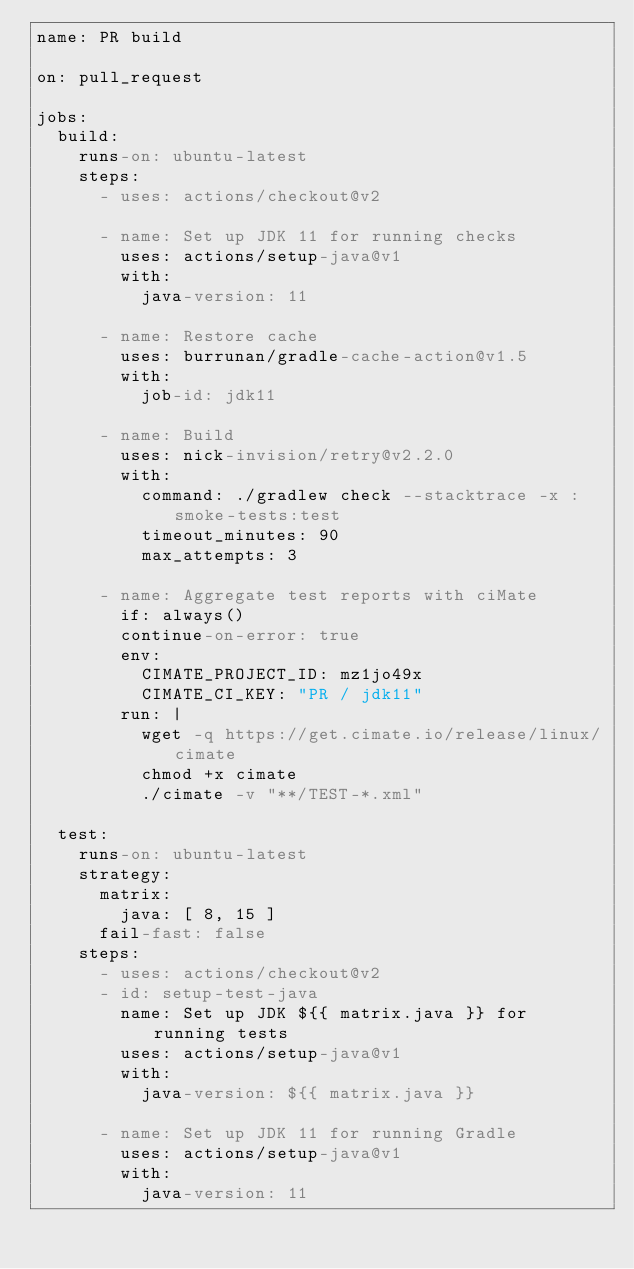<code> <loc_0><loc_0><loc_500><loc_500><_YAML_>name: PR build

on: pull_request

jobs:
  build:
    runs-on: ubuntu-latest
    steps:
      - uses: actions/checkout@v2

      - name: Set up JDK 11 for running checks
        uses: actions/setup-java@v1
        with:
          java-version: 11

      - name: Restore cache
        uses: burrunan/gradle-cache-action@v1.5
        with:
          job-id: jdk11

      - name: Build
        uses: nick-invision/retry@v2.2.0
        with:
          command: ./gradlew check --stacktrace -x :smoke-tests:test
          timeout_minutes: 90
          max_attempts: 3

      - name: Aggregate test reports with ciMate
        if: always()
        continue-on-error: true
        env:
          CIMATE_PROJECT_ID: mz1jo49x
          CIMATE_CI_KEY: "PR / jdk11"
        run: |
          wget -q https://get.cimate.io/release/linux/cimate
          chmod +x cimate
          ./cimate -v "**/TEST-*.xml"

  test:
    runs-on: ubuntu-latest
    strategy:
      matrix:
        java: [ 8, 15 ]
      fail-fast: false
    steps:
      - uses: actions/checkout@v2
      - id: setup-test-java
        name: Set up JDK ${{ matrix.java }} for running tests
        uses: actions/setup-java@v1
        with:
          java-version: ${{ matrix.java }}

      - name: Set up JDK 11 for running Gradle
        uses: actions/setup-java@v1
        with:
          java-version: 11
</code> 